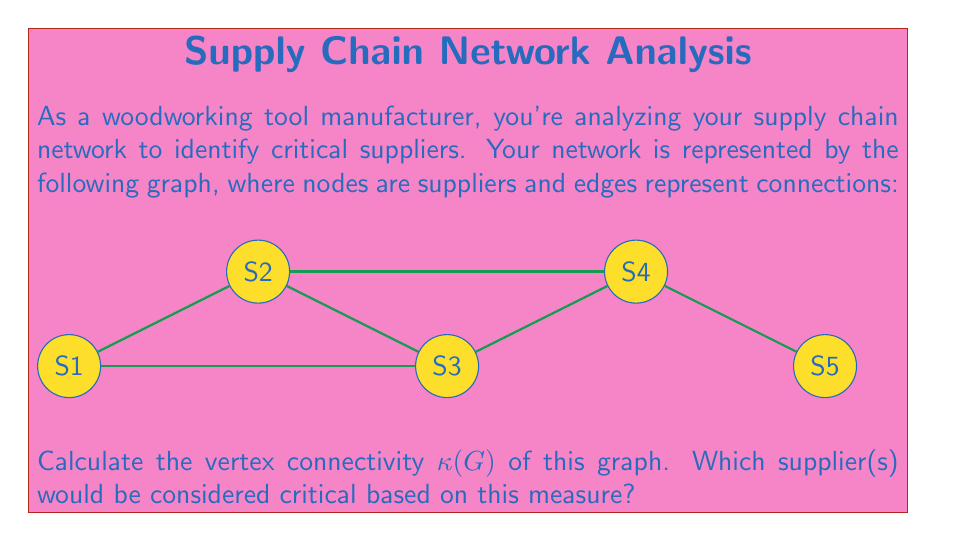Give your solution to this math problem. To solve this problem, we'll follow these steps:

1) First, recall that the vertex connectivity $\kappa(G)$ of a graph G is the minimum number of vertices whose removal disconnects the graph.

2) In this graph, we need to check how many vertices need to be removed to disconnect it.

3) Let's consider removing vertices one by one:
   - Removing S1 or S5 doesn't disconnect the graph.
   - Removing S2 or S4 also doesn't disconnect the graph.
   - However, removing S3 disconnects the graph into two components: {S1, S2} and {S4, S5}.

4) Since removing one vertex (S3) is sufficient to disconnect the graph, we can conclude that $\kappa(G) = 1$.

5) In graph theory, vertices whose removal increases the number of connected components are called cut vertices or articulation points.

6) In the context of supply chain networks, cut vertices represent critical suppliers because their removal would disrupt the flow of materials or information in the network.

7) Therefore, S3 is the only critical supplier in this network based on the vertex connectivity measure.
Answer: $\kappa(G) = 1$; S3 is the critical supplier. 